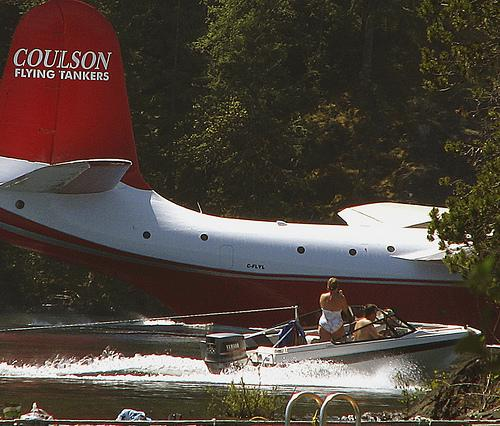Based on the circumstances of the image what method of transportation currently moves the fastest?

Choices:
A) walking
B) airplane
C) motorboat
D) swimming motorboat 